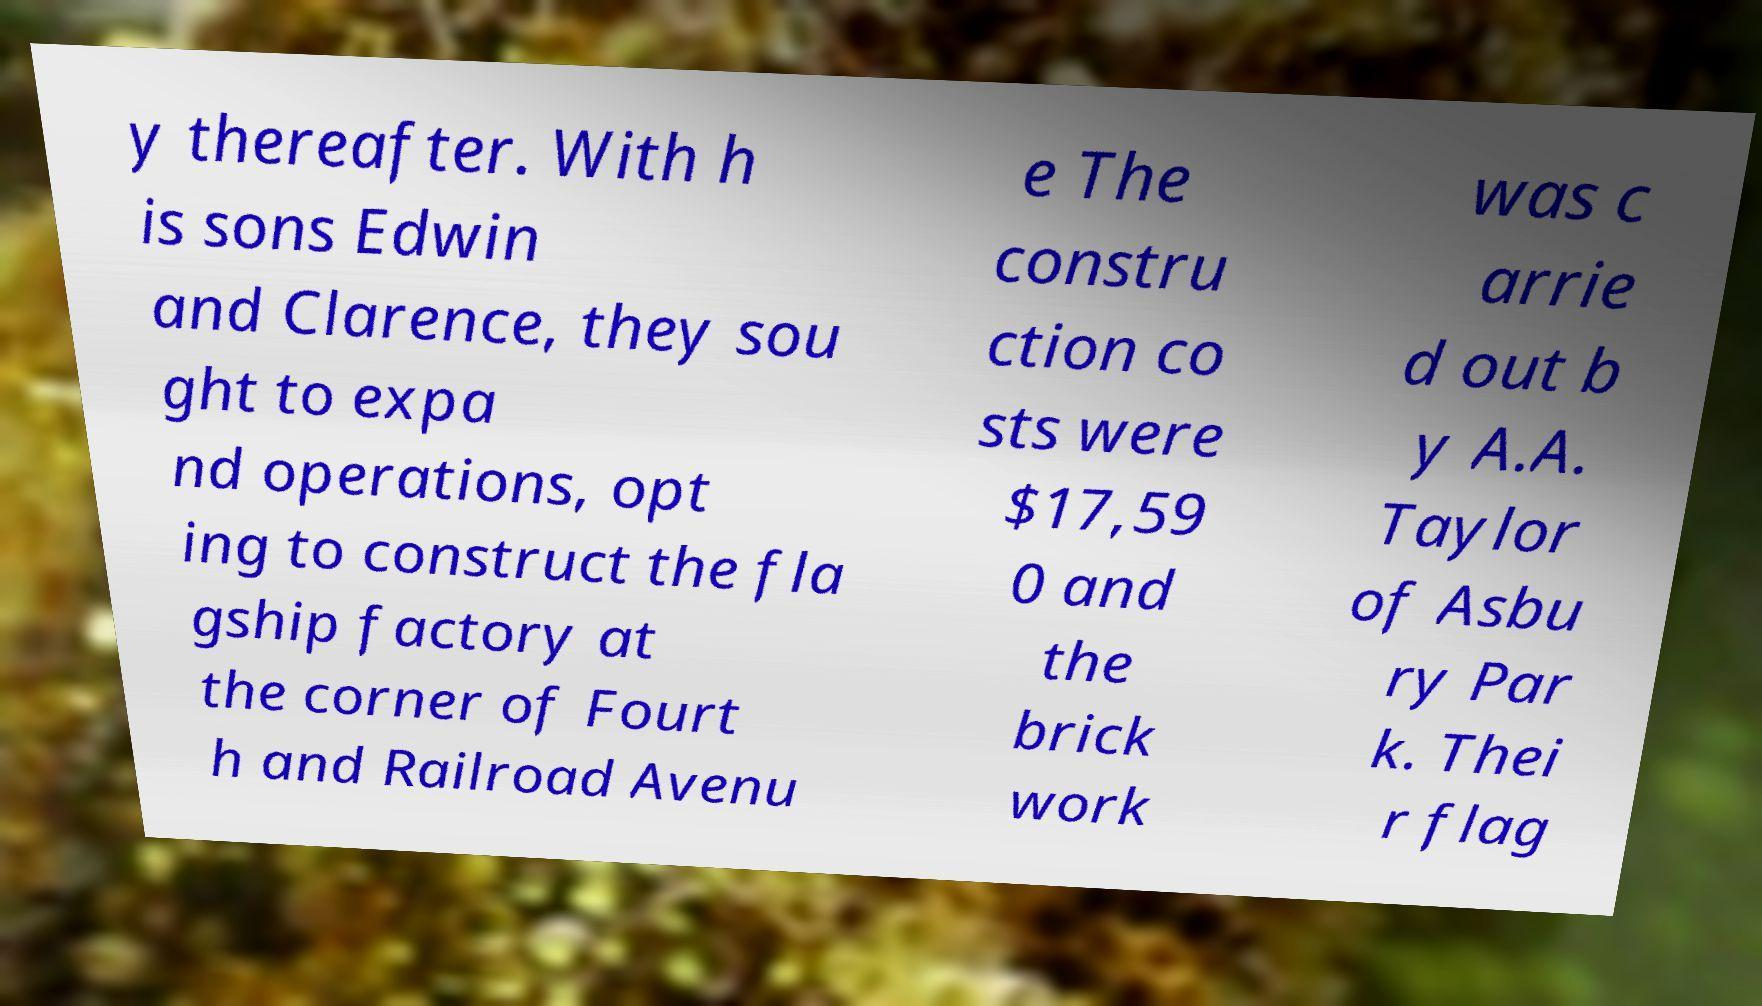Could you extract and type out the text from this image? y thereafter. With h is sons Edwin and Clarence, they sou ght to expa nd operations, opt ing to construct the fla gship factory at the corner of Fourt h and Railroad Avenu e The constru ction co sts were $17,59 0 and the brick work was c arrie d out b y A.A. Taylor of Asbu ry Par k. Thei r flag 